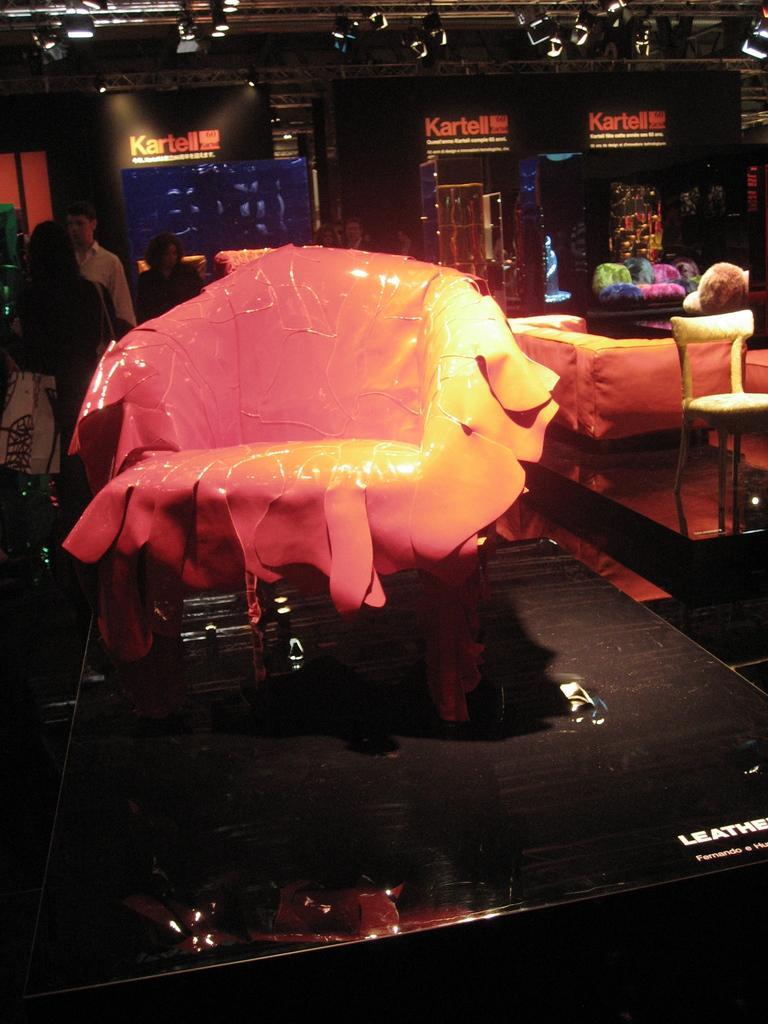How would you summarize this image in a sentence or two? In the image there is a chair in the middle and to the left side there are few people standing and to the right side corner there are sofas and pillows on it. At the top there is a ceiling to which there are lights. 